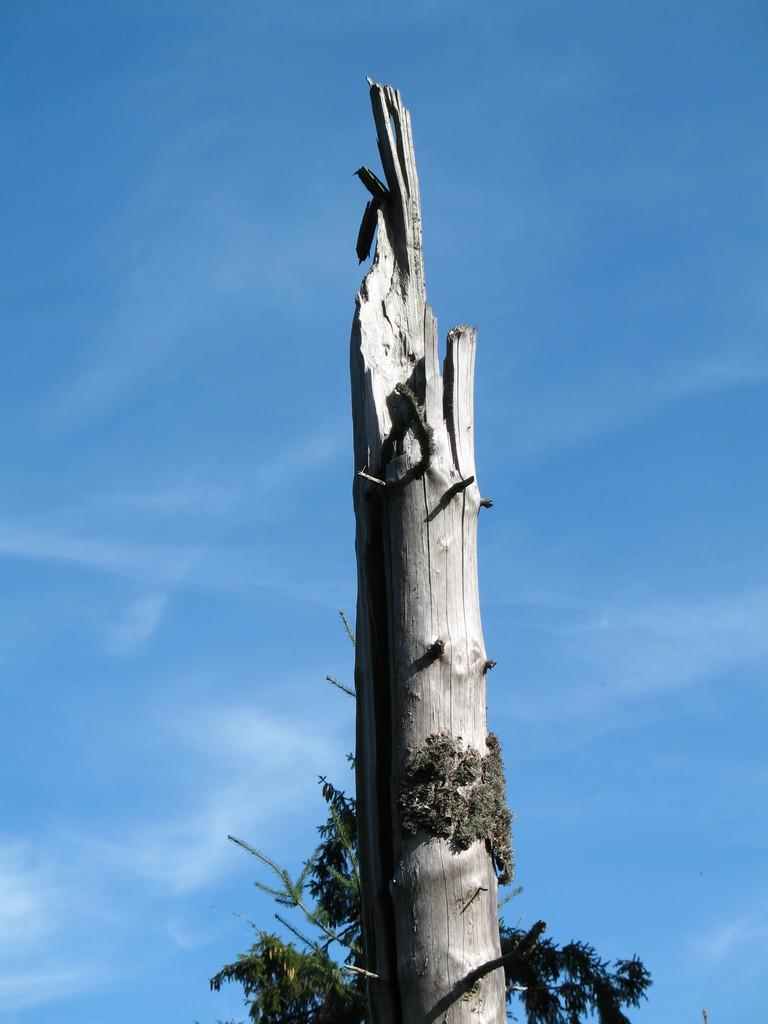What is the main subject in the image? There is a tree trunk in the image. What can be seen in the background of the image? There is a sky visible in the background of the image. What is present in the sky in the background of the image? Clouds are present in the sky in the background of the image. Where is the store located in the image? There is no store present in the image. How many tomatoes are hanging from the tree trunk in the image? There are no tomatoes present in the image. What type of slip can be seen on the tree trunk in the image? There is no slip present on the tree trunk in the image. 